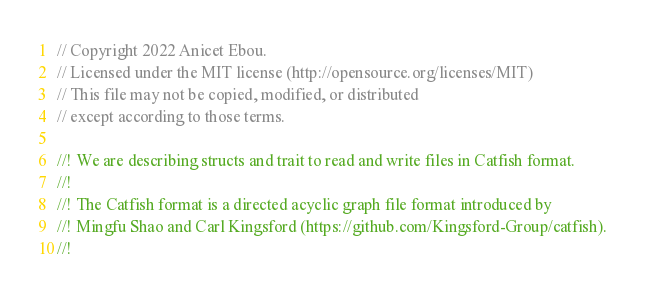<code> <loc_0><loc_0><loc_500><loc_500><_Rust_>// Copyright 2022 Anicet Ebou.
// Licensed under the MIT license (http://opensource.org/licenses/MIT)
// This file may not be copied, modified, or distributed
// except according to those terms.

//! We are describing structs and trait to read and write files in Catfish format.
//!
//! The Catfish format is a directed acyclic graph file format introduced by
//! Mingfu Shao and Carl Kingsford (https://github.com/Kingsford-Group/catfish).
//!</code> 